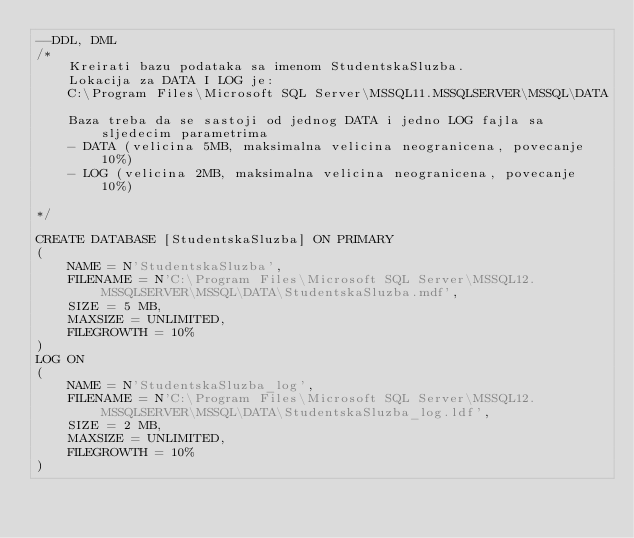Convert code to text. <code><loc_0><loc_0><loc_500><loc_500><_SQL_>--DDL, DML
/*
	Kreirati bazu podataka sa imenom StudentskaSluzba.
	Lokacija za DATA I LOG je:
	C:\Program Files\Microsoft SQL Server\MSSQL11.MSSQLSERVER\MSSQL\DATA

	Baza treba da se sastoji od jednog DATA i jedno LOG fajla sa sljedecim parametrima
	- DATA (velicina 5MB, maksimalna velicina neogranicena, povecanje 10%)
	- LOG (velicina 2MB, maksimalna velicina neogranicena, povecanje 10%)

*/

CREATE DATABASE [StudentskaSluzba] ON PRIMARY
(
	NAME = N'StudentskaSluzba',
	FILENAME = N'C:\Program Files\Microsoft SQL Server\MSSQL12.MSSQLSERVER\MSSQL\DATA\StudentskaSluzba.mdf',
	SIZE = 5 MB,
	MAXSIZE = UNLIMITED,
	FILEGROWTH = 10%
)
LOG ON
(
	NAME = N'StudentskaSluzba_log',
	FILENAME = N'C:\Program Files\Microsoft SQL Server\MSSQL12.MSSQLSERVER\MSSQL\DATA\StudentskaSluzba_log.ldf',
	SIZE = 2 MB,
	MAXSIZE = UNLIMITED,
	FILEGROWTH = 10%
)</code> 